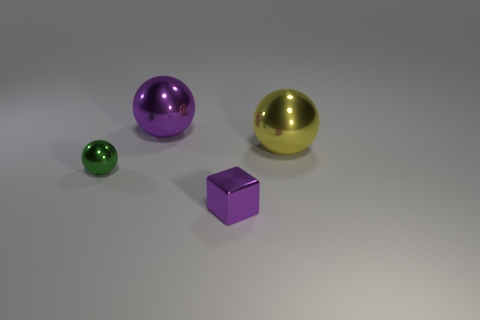How many balls are either small blue matte things or small objects? 1 